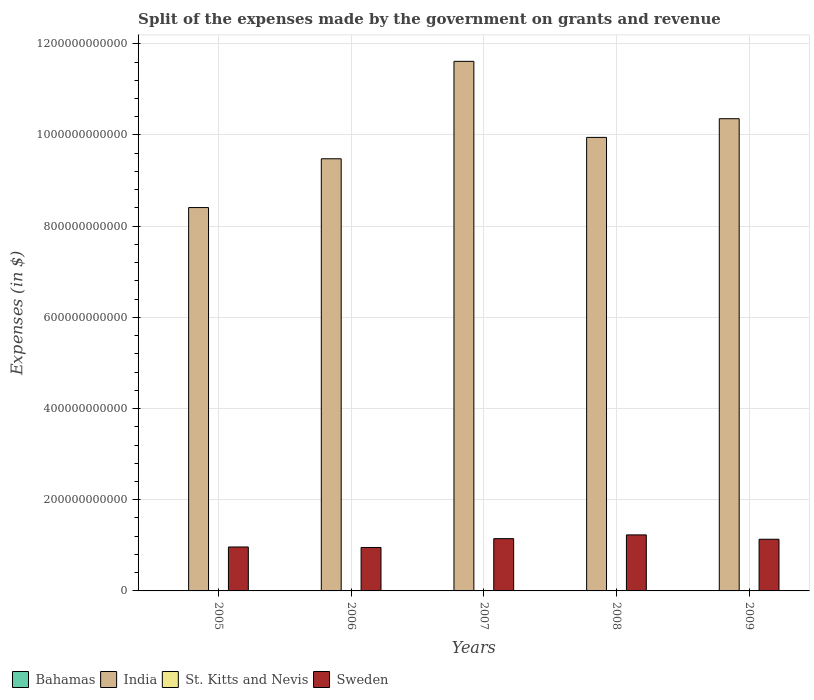In how many cases, is the number of bars for a given year not equal to the number of legend labels?
Your answer should be very brief. 0. What is the expenses made by the government on grants and revenue in St. Kitts and Nevis in 2007?
Give a very brief answer. 1.45e+08. Across all years, what is the maximum expenses made by the government on grants and revenue in India?
Keep it short and to the point. 1.16e+12. Across all years, what is the minimum expenses made by the government on grants and revenue in India?
Your answer should be very brief. 8.41e+11. In which year was the expenses made by the government on grants and revenue in St. Kitts and Nevis maximum?
Offer a terse response. 2009. In which year was the expenses made by the government on grants and revenue in Bahamas minimum?
Give a very brief answer. 2005. What is the total expenses made by the government on grants and revenue in Bahamas in the graph?
Offer a very short reply. 7.34e+08. What is the difference between the expenses made by the government on grants and revenue in Sweden in 2006 and that in 2007?
Ensure brevity in your answer.  -1.94e+1. What is the difference between the expenses made by the government on grants and revenue in India in 2008 and the expenses made by the government on grants and revenue in Sweden in 2006?
Offer a terse response. 8.99e+11. What is the average expenses made by the government on grants and revenue in Bahamas per year?
Keep it short and to the point. 1.47e+08. In the year 2009, what is the difference between the expenses made by the government on grants and revenue in Sweden and expenses made by the government on grants and revenue in Bahamas?
Provide a succinct answer. 1.13e+11. What is the ratio of the expenses made by the government on grants and revenue in India in 2005 to that in 2007?
Your answer should be very brief. 0.72. Is the expenses made by the government on grants and revenue in India in 2005 less than that in 2009?
Your answer should be very brief. Yes. Is the difference between the expenses made by the government on grants and revenue in Sweden in 2006 and 2008 greater than the difference between the expenses made by the government on grants and revenue in Bahamas in 2006 and 2008?
Give a very brief answer. No. What is the difference between the highest and the second highest expenses made by the government on grants and revenue in Sweden?
Your answer should be very brief. 8.23e+09. What is the difference between the highest and the lowest expenses made by the government on grants and revenue in India?
Your response must be concise. 3.21e+11. In how many years, is the expenses made by the government on grants and revenue in St. Kitts and Nevis greater than the average expenses made by the government on grants and revenue in St. Kitts and Nevis taken over all years?
Provide a short and direct response. 1. Is it the case that in every year, the sum of the expenses made by the government on grants and revenue in St. Kitts and Nevis and expenses made by the government on grants and revenue in Bahamas is greater than the sum of expenses made by the government on grants and revenue in Sweden and expenses made by the government on grants and revenue in India?
Provide a short and direct response. No. What does the 2nd bar from the left in 2008 represents?
Keep it short and to the point. India. What does the 3rd bar from the right in 2007 represents?
Offer a terse response. India. How many bars are there?
Give a very brief answer. 20. How many years are there in the graph?
Make the answer very short. 5. What is the difference between two consecutive major ticks on the Y-axis?
Your response must be concise. 2.00e+11. Are the values on the major ticks of Y-axis written in scientific E-notation?
Ensure brevity in your answer.  No. Does the graph contain any zero values?
Offer a terse response. No. How are the legend labels stacked?
Keep it short and to the point. Horizontal. What is the title of the graph?
Your answer should be compact. Split of the expenses made by the government on grants and revenue. Does "Brazil" appear as one of the legend labels in the graph?
Provide a succinct answer. No. What is the label or title of the X-axis?
Offer a terse response. Years. What is the label or title of the Y-axis?
Your answer should be very brief. Expenses (in $). What is the Expenses (in $) of Bahamas in 2005?
Provide a short and direct response. 1.21e+08. What is the Expenses (in $) of India in 2005?
Your answer should be very brief. 8.41e+11. What is the Expenses (in $) of St. Kitts and Nevis in 2005?
Keep it short and to the point. 1.22e+08. What is the Expenses (in $) of Sweden in 2005?
Make the answer very short. 9.64e+1. What is the Expenses (in $) in Bahamas in 2006?
Offer a very short reply. 1.37e+08. What is the Expenses (in $) of India in 2006?
Keep it short and to the point. 9.48e+11. What is the Expenses (in $) in St. Kitts and Nevis in 2006?
Provide a short and direct response. 1.44e+08. What is the Expenses (in $) of Sweden in 2006?
Offer a terse response. 9.53e+1. What is the Expenses (in $) in Bahamas in 2007?
Offer a terse response. 1.30e+08. What is the Expenses (in $) of India in 2007?
Offer a very short reply. 1.16e+12. What is the Expenses (in $) of St. Kitts and Nevis in 2007?
Your response must be concise. 1.45e+08. What is the Expenses (in $) in Sweden in 2007?
Your answer should be very brief. 1.15e+11. What is the Expenses (in $) of Bahamas in 2008?
Provide a short and direct response. 1.53e+08. What is the Expenses (in $) of India in 2008?
Provide a succinct answer. 9.95e+11. What is the Expenses (in $) of St. Kitts and Nevis in 2008?
Offer a terse response. 1.50e+08. What is the Expenses (in $) of Sweden in 2008?
Your answer should be compact. 1.23e+11. What is the Expenses (in $) in Bahamas in 2009?
Make the answer very short. 1.93e+08. What is the Expenses (in $) of India in 2009?
Provide a short and direct response. 1.04e+12. What is the Expenses (in $) of St. Kitts and Nevis in 2009?
Your answer should be compact. 2.10e+08. What is the Expenses (in $) in Sweden in 2009?
Offer a very short reply. 1.13e+11. Across all years, what is the maximum Expenses (in $) of Bahamas?
Ensure brevity in your answer.  1.93e+08. Across all years, what is the maximum Expenses (in $) in India?
Ensure brevity in your answer.  1.16e+12. Across all years, what is the maximum Expenses (in $) of St. Kitts and Nevis?
Give a very brief answer. 2.10e+08. Across all years, what is the maximum Expenses (in $) in Sweden?
Make the answer very short. 1.23e+11. Across all years, what is the minimum Expenses (in $) of Bahamas?
Offer a very short reply. 1.21e+08. Across all years, what is the minimum Expenses (in $) of India?
Provide a succinct answer. 8.41e+11. Across all years, what is the minimum Expenses (in $) of St. Kitts and Nevis?
Your answer should be compact. 1.22e+08. Across all years, what is the minimum Expenses (in $) in Sweden?
Your response must be concise. 9.53e+1. What is the total Expenses (in $) of Bahamas in the graph?
Give a very brief answer. 7.34e+08. What is the total Expenses (in $) of India in the graph?
Your answer should be compact. 4.98e+12. What is the total Expenses (in $) in St. Kitts and Nevis in the graph?
Offer a very short reply. 7.71e+08. What is the total Expenses (in $) of Sweden in the graph?
Your answer should be compact. 5.42e+11. What is the difference between the Expenses (in $) of Bahamas in 2005 and that in 2006?
Your response must be concise. -1.59e+07. What is the difference between the Expenses (in $) of India in 2005 and that in 2006?
Provide a succinct answer. -1.07e+11. What is the difference between the Expenses (in $) of St. Kitts and Nevis in 2005 and that in 2006?
Make the answer very short. -2.26e+07. What is the difference between the Expenses (in $) of Sweden in 2005 and that in 2006?
Make the answer very short. 1.08e+09. What is the difference between the Expenses (in $) in Bahamas in 2005 and that in 2007?
Make the answer very short. -9.02e+06. What is the difference between the Expenses (in $) of India in 2005 and that in 2007?
Offer a terse response. -3.21e+11. What is the difference between the Expenses (in $) in St. Kitts and Nevis in 2005 and that in 2007?
Your answer should be very brief. -2.32e+07. What is the difference between the Expenses (in $) in Sweden in 2005 and that in 2007?
Provide a short and direct response. -1.83e+1. What is the difference between the Expenses (in $) of Bahamas in 2005 and that in 2008?
Offer a terse response. -3.18e+07. What is the difference between the Expenses (in $) of India in 2005 and that in 2008?
Your answer should be very brief. -1.54e+11. What is the difference between the Expenses (in $) of St. Kitts and Nevis in 2005 and that in 2008?
Make the answer very short. -2.87e+07. What is the difference between the Expenses (in $) of Sweden in 2005 and that in 2008?
Keep it short and to the point. -2.65e+1. What is the difference between the Expenses (in $) in Bahamas in 2005 and that in 2009?
Offer a terse response. -7.23e+07. What is the difference between the Expenses (in $) in India in 2005 and that in 2009?
Offer a very short reply. -1.95e+11. What is the difference between the Expenses (in $) in St. Kitts and Nevis in 2005 and that in 2009?
Offer a terse response. -8.77e+07. What is the difference between the Expenses (in $) of Sweden in 2005 and that in 2009?
Provide a short and direct response. -1.70e+1. What is the difference between the Expenses (in $) of Bahamas in 2006 and that in 2007?
Keep it short and to the point. 6.84e+06. What is the difference between the Expenses (in $) in India in 2006 and that in 2007?
Make the answer very short. -2.14e+11. What is the difference between the Expenses (in $) of St. Kitts and Nevis in 2006 and that in 2007?
Give a very brief answer. -6.00e+05. What is the difference between the Expenses (in $) in Sweden in 2006 and that in 2007?
Provide a short and direct response. -1.94e+1. What is the difference between the Expenses (in $) of Bahamas in 2006 and that in 2008?
Offer a terse response. -1.60e+07. What is the difference between the Expenses (in $) in India in 2006 and that in 2008?
Your answer should be very brief. -4.69e+1. What is the difference between the Expenses (in $) in St. Kitts and Nevis in 2006 and that in 2008?
Your answer should be compact. -6.10e+06. What is the difference between the Expenses (in $) in Sweden in 2006 and that in 2008?
Keep it short and to the point. -2.76e+1. What is the difference between the Expenses (in $) in Bahamas in 2006 and that in 2009?
Provide a succinct answer. -5.65e+07. What is the difference between the Expenses (in $) in India in 2006 and that in 2009?
Your answer should be compact. -8.79e+1. What is the difference between the Expenses (in $) of St. Kitts and Nevis in 2006 and that in 2009?
Your answer should be very brief. -6.51e+07. What is the difference between the Expenses (in $) in Sweden in 2006 and that in 2009?
Provide a succinct answer. -1.81e+1. What is the difference between the Expenses (in $) of Bahamas in 2007 and that in 2008?
Make the answer very short. -2.28e+07. What is the difference between the Expenses (in $) of India in 2007 and that in 2008?
Offer a terse response. 1.67e+11. What is the difference between the Expenses (in $) of St. Kitts and Nevis in 2007 and that in 2008?
Keep it short and to the point. -5.50e+06. What is the difference between the Expenses (in $) in Sweden in 2007 and that in 2008?
Give a very brief answer. -8.23e+09. What is the difference between the Expenses (in $) of Bahamas in 2007 and that in 2009?
Your answer should be very brief. -6.33e+07. What is the difference between the Expenses (in $) of India in 2007 and that in 2009?
Ensure brevity in your answer.  1.26e+11. What is the difference between the Expenses (in $) in St. Kitts and Nevis in 2007 and that in 2009?
Ensure brevity in your answer.  -6.45e+07. What is the difference between the Expenses (in $) in Sweden in 2007 and that in 2009?
Ensure brevity in your answer.  1.31e+09. What is the difference between the Expenses (in $) in Bahamas in 2008 and that in 2009?
Ensure brevity in your answer.  -4.05e+07. What is the difference between the Expenses (in $) of India in 2008 and that in 2009?
Your answer should be very brief. -4.10e+1. What is the difference between the Expenses (in $) of St. Kitts and Nevis in 2008 and that in 2009?
Provide a short and direct response. -5.90e+07. What is the difference between the Expenses (in $) of Sweden in 2008 and that in 2009?
Your response must be concise. 9.54e+09. What is the difference between the Expenses (in $) of Bahamas in 2005 and the Expenses (in $) of India in 2006?
Make the answer very short. -9.48e+11. What is the difference between the Expenses (in $) of Bahamas in 2005 and the Expenses (in $) of St. Kitts and Nevis in 2006?
Keep it short and to the point. -2.34e+07. What is the difference between the Expenses (in $) in Bahamas in 2005 and the Expenses (in $) in Sweden in 2006?
Your response must be concise. -9.51e+1. What is the difference between the Expenses (in $) in India in 2005 and the Expenses (in $) in St. Kitts and Nevis in 2006?
Keep it short and to the point. 8.41e+11. What is the difference between the Expenses (in $) in India in 2005 and the Expenses (in $) in Sweden in 2006?
Your answer should be compact. 7.45e+11. What is the difference between the Expenses (in $) in St. Kitts and Nevis in 2005 and the Expenses (in $) in Sweden in 2006?
Make the answer very short. -9.51e+1. What is the difference between the Expenses (in $) of Bahamas in 2005 and the Expenses (in $) of India in 2007?
Your response must be concise. -1.16e+12. What is the difference between the Expenses (in $) of Bahamas in 2005 and the Expenses (in $) of St. Kitts and Nevis in 2007?
Provide a succinct answer. -2.40e+07. What is the difference between the Expenses (in $) of Bahamas in 2005 and the Expenses (in $) of Sweden in 2007?
Ensure brevity in your answer.  -1.15e+11. What is the difference between the Expenses (in $) in India in 2005 and the Expenses (in $) in St. Kitts and Nevis in 2007?
Provide a succinct answer. 8.41e+11. What is the difference between the Expenses (in $) of India in 2005 and the Expenses (in $) of Sweden in 2007?
Give a very brief answer. 7.26e+11. What is the difference between the Expenses (in $) of St. Kitts and Nevis in 2005 and the Expenses (in $) of Sweden in 2007?
Your response must be concise. -1.15e+11. What is the difference between the Expenses (in $) in Bahamas in 2005 and the Expenses (in $) in India in 2008?
Your answer should be compact. -9.95e+11. What is the difference between the Expenses (in $) of Bahamas in 2005 and the Expenses (in $) of St. Kitts and Nevis in 2008?
Offer a very short reply. -2.95e+07. What is the difference between the Expenses (in $) in Bahamas in 2005 and the Expenses (in $) in Sweden in 2008?
Provide a succinct answer. -1.23e+11. What is the difference between the Expenses (in $) of India in 2005 and the Expenses (in $) of St. Kitts and Nevis in 2008?
Your answer should be very brief. 8.41e+11. What is the difference between the Expenses (in $) in India in 2005 and the Expenses (in $) in Sweden in 2008?
Provide a short and direct response. 7.18e+11. What is the difference between the Expenses (in $) of St. Kitts and Nevis in 2005 and the Expenses (in $) of Sweden in 2008?
Your answer should be very brief. -1.23e+11. What is the difference between the Expenses (in $) in Bahamas in 2005 and the Expenses (in $) in India in 2009?
Ensure brevity in your answer.  -1.04e+12. What is the difference between the Expenses (in $) of Bahamas in 2005 and the Expenses (in $) of St. Kitts and Nevis in 2009?
Provide a succinct answer. -8.85e+07. What is the difference between the Expenses (in $) in Bahamas in 2005 and the Expenses (in $) in Sweden in 2009?
Ensure brevity in your answer.  -1.13e+11. What is the difference between the Expenses (in $) of India in 2005 and the Expenses (in $) of St. Kitts and Nevis in 2009?
Keep it short and to the point. 8.41e+11. What is the difference between the Expenses (in $) in India in 2005 and the Expenses (in $) in Sweden in 2009?
Ensure brevity in your answer.  7.27e+11. What is the difference between the Expenses (in $) in St. Kitts and Nevis in 2005 and the Expenses (in $) in Sweden in 2009?
Provide a succinct answer. -1.13e+11. What is the difference between the Expenses (in $) of Bahamas in 2006 and the Expenses (in $) of India in 2007?
Provide a succinct answer. -1.16e+12. What is the difference between the Expenses (in $) in Bahamas in 2006 and the Expenses (in $) in St. Kitts and Nevis in 2007?
Make the answer very short. -8.17e+06. What is the difference between the Expenses (in $) of Bahamas in 2006 and the Expenses (in $) of Sweden in 2007?
Offer a very short reply. -1.15e+11. What is the difference between the Expenses (in $) of India in 2006 and the Expenses (in $) of St. Kitts and Nevis in 2007?
Offer a terse response. 9.48e+11. What is the difference between the Expenses (in $) of India in 2006 and the Expenses (in $) of Sweden in 2007?
Offer a terse response. 8.33e+11. What is the difference between the Expenses (in $) of St. Kitts and Nevis in 2006 and the Expenses (in $) of Sweden in 2007?
Keep it short and to the point. -1.14e+11. What is the difference between the Expenses (in $) in Bahamas in 2006 and the Expenses (in $) in India in 2008?
Offer a terse response. -9.95e+11. What is the difference between the Expenses (in $) of Bahamas in 2006 and the Expenses (in $) of St. Kitts and Nevis in 2008?
Provide a succinct answer. -1.37e+07. What is the difference between the Expenses (in $) of Bahamas in 2006 and the Expenses (in $) of Sweden in 2008?
Make the answer very short. -1.23e+11. What is the difference between the Expenses (in $) in India in 2006 and the Expenses (in $) in St. Kitts and Nevis in 2008?
Keep it short and to the point. 9.48e+11. What is the difference between the Expenses (in $) in India in 2006 and the Expenses (in $) in Sweden in 2008?
Keep it short and to the point. 8.25e+11. What is the difference between the Expenses (in $) of St. Kitts and Nevis in 2006 and the Expenses (in $) of Sweden in 2008?
Provide a short and direct response. -1.23e+11. What is the difference between the Expenses (in $) of Bahamas in 2006 and the Expenses (in $) of India in 2009?
Provide a succinct answer. -1.04e+12. What is the difference between the Expenses (in $) in Bahamas in 2006 and the Expenses (in $) in St. Kitts and Nevis in 2009?
Provide a succinct answer. -7.27e+07. What is the difference between the Expenses (in $) of Bahamas in 2006 and the Expenses (in $) of Sweden in 2009?
Offer a very short reply. -1.13e+11. What is the difference between the Expenses (in $) of India in 2006 and the Expenses (in $) of St. Kitts and Nevis in 2009?
Make the answer very short. 9.48e+11. What is the difference between the Expenses (in $) of India in 2006 and the Expenses (in $) of Sweden in 2009?
Your answer should be compact. 8.34e+11. What is the difference between the Expenses (in $) in St. Kitts and Nevis in 2006 and the Expenses (in $) in Sweden in 2009?
Make the answer very short. -1.13e+11. What is the difference between the Expenses (in $) of Bahamas in 2007 and the Expenses (in $) of India in 2008?
Provide a short and direct response. -9.95e+11. What is the difference between the Expenses (in $) of Bahamas in 2007 and the Expenses (in $) of St. Kitts and Nevis in 2008?
Provide a short and direct response. -2.05e+07. What is the difference between the Expenses (in $) in Bahamas in 2007 and the Expenses (in $) in Sweden in 2008?
Keep it short and to the point. -1.23e+11. What is the difference between the Expenses (in $) in India in 2007 and the Expenses (in $) in St. Kitts and Nevis in 2008?
Provide a succinct answer. 1.16e+12. What is the difference between the Expenses (in $) of India in 2007 and the Expenses (in $) of Sweden in 2008?
Your answer should be compact. 1.04e+12. What is the difference between the Expenses (in $) in St. Kitts and Nevis in 2007 and the Expenses (in $) in Sweden in 2008?
Give a very brief answer. -1.23e+11. What is the difference between the Expenses (in $) in Bahamas in 2007 and the Expenses (in $) in India in 2009?
Keep it short and to the point. -1.04e+12. What is the difference between the Expenses (in $) in Bahamas in 2007 and the Expenses (in $) in St. Kitts and Nevis in 2009?
Make the answer very short. -7.95e+07. What is the difference between the Expenses (in $) in Bahamas in 2007 and the Expenses (in $) in Sweden in 2009?
Make the answer very short. -1.13e+11. What is the difference between the Expenses (in $) in India in 2007 and the Expenses (in $) in St. Kitts and Nevis in 2009?
Make the answer very short. 1.16e+12. What is the difference between the Expenses (in $) in India in 2007 and the Expenses (in $) in Sweden in 2009?
Your answer should be very brief. 1.05e+12. What is the difference between the Expenses (in $) in St. Kitts and Nevis in 2007 and the Expenses (in $) in Sweden in 2009?
Offer a very short reply. -1.13e+11. What is the difference between the Expenses (in $) of Bahamas in 2008 and the Expenses (in $) of India in 2009?
Provide a succinct answer. -1.04e+12. What is the difference between the Expenses (in $) of Bahamas in 2008 and the Expenses (in $) of St. Kitts and Nevis in 2009?
Provide a short and direct response. -5.67e+07. What is the difference between the Expenses (in $) of Bahamas in 2008 and the Expenses (in $) of Sweden in 2009?
Provide a succinct answer. -1.13e+11. What is the difference between the Expenses (in $) in India in 2008 and the Expenses (in $) in St. Kitts and Nevis in 2009?
Your answer should be very brief. 9.94e+11. What is the difference between the Expenses (in $) in India in 2008 and the Expenses (in $) in Sweden in 2009?
Keep it short and to the point. 8.81e+11. What is the difference between the Expenses (in $) of St. Kitts and Nevis in 2008 and the Expenses (in $) of Sweden in 2009?
Your response must be concise. -1.13e+11. What is the average Expenses (in $) of Bahamas per year?
Provide a succinct answer. 1.47e+08. What is the average Expenses (in $) of India per year?
Provide a succinct answer. 9.96e+11. What is the average Expenses (in $) in St. Kitts and Nevis per year?
Your answer should be compact. 1.54e+08. What is the average Expenses (in $) in Sweden per year?
Keep it short and to the point. 1.08e+11. In the year 2005, what is the difference between the Expenses (in $) of Bahamas and Expenses (in $) of India?
Provide a short and direct response. -8.41e+11. In the year 2005, what is the difference between the Expenses (in $) in Bahamas and Expenses (in $) in St. Kitts and Nevis?
Your answer should be very brief. -8.21e+05. In the year 2005, what is the difference between the Expenses (in $) of Bahamas and Expenses (in $) of Sweden?
Provide a short and direct response. -9.62e+1. In the year 2005, what is the difference between the Expenses (in $) in India and Expenses (in $) in St. Kitts and Nevis?
Give a very brief answer. 8.41e+11. In the year 2005, what is the difference between the Expenses (in $) of India and Expenses (in $) of Sweden?
Offer a very short reply. 7.44e+11. In the year 2005, what is the difference between the Expenses (in $) in St. Kitts and Nevis and Expenses (in $) in Sweden?
Keep it short and to the point. -9.62e+1. In the year 2006, what is the difference between the Expenses (in $) of Bahamas and Expenses (in $) of India?
Ensure brevity in your answer.  -9.48e+11. In the year 2006, what is the difference between the Expenses (in $) in Bahamas and Expenses (in $) in St. Kitts and Nevis?
Make the answer very short. -7.57e+06. In the year 2006, what is the difference between the Expenses (in $) of Bahamas and Expenses (in $) of Sweden?
Your response must be concise. -9.51e+1. In the year 2006, what is the difference between the Expenses (in $) in India and Expenses (in $) in St. Kitts and Nevis?
Your response must be concise. 9.48e+11. In the year 2006, what is the difference between the Expenses (in $) in India and Expenses (in $) in Sweden?
Give a very brief answer. 8.52e+11. In the year 2006, what is the difference between the Expenses (in $) in St. Kitts and Nevis and Expenses (in $) in Sweden?
Your answer should be very brief. -9.51e+1. In the year 2007, what is the difference between the Expenses (in $) in Bahamas and Expenses (in $) in India?
Give a very brief answer. -1.16e+12. In the year 2007, what is the difference between the Expenses (in $) in Bahamas and Expenses (in $) in St. Kitts and Nevis?
Your response must be concise. -1.50e+07. In the year 2007, what is the difference between the Expenses (in $) of Bahamas and Expenses (in $) of Sweden?
Your answer should be compact. -1.15e+11. In the year 2007, what is the difference between the Expenses (in $) in India and Expenses (in $) in St. Kitts and Nevis?
Make the answer very short. 1.16e+12. In the year 2007, what is the difference between the Expenses (in $) in India and Expenses (in $) in Sweden?
Offer a terse response. 1.05e+12. In the year 2007, what is the difference between the Expenses (in $) of St. Kitts and Nevis and Expenses (in $) of Sweden?
Offer a terse response. -1.14e+11. In the year 2008, what is the difference between the Expenses (in $) in Bahamas and Expenses (in $) in India?
Your response must be concise. -9.94e+11. In the year 2008, what is the difference between the Expenses (in $) in Bahamas and Expenses (in $) in St. Kitts and Nevis?
Your answer should be compact. 2.31e+06. In the year 2008, what is the difference between the Expenses (in $) in Bahamas and Expenses (in $) in Sweden?
Your answer should be compact. -1.23e+11. In the year 2008, what is the difference between the Expenses (in $) of India and Expenses (in $) of St. Kitts and Nevis?
Offer a very short reply. 9.94e+11. In the year 2008, what is the difference between the Expenses (in $) in India and Expenses (in $) in Sweden?
Offer a very short reply. 8.72e+11. In the year 2008, what is the difference between the Expenses (in $) of St. Kitts and Nevis and Expenses (in $) of Sweden?
Provide a short and direct response. -1.23e+11. In the year 2009, what is the difference between the Expenses (in $) of Bahamas and Expenses (in $) of India?
Provide a short and direct response. -1.04e+12. In the year 2009, what is the difference between the Expenses (in $) of Bahamas and Expenses (in $) of St. Kitts and Nevis?
Offer a terse response. -1.62e+07. In the year 2009, what is the difference between the Expenses (in $) of Bahamas and Expenses (in $) of Sweden?
Keep it short and to the point. -1.13e+11. In the year 2009, what is the difference between the Expenses (in $) in India and Expenses (in $) in St. Kitts and Nevis?
Your response must be concise. 1.04e+12. In the year 2009, what is the difference between the Expenses (in $) of India and Expenses (in $) of Sweden?
Make the answer very short. 9.22e+11. In the year 2009, what is the difference between the Expenses (in $) in St. Kitts and Nevis and Expenses (in $) in Sweden?
Provide a short and direct response. -1.13e+11. What is the ratio of the Expenses (in $) of Bahamas in 2005 to that in 2006?
Your answer should be compact. 0.88. What is the ratio of the Expenses (in $) in India in 2005 to that in 2006?
Your answer should be compact. 0.89. What is the ratio of the Expenses (in $) in St. Kitts and Nevis in 2005 to that in 2006?
Make the answer very short. 0.84. What is the ratio of the Expenses (in $) of Sweden in 2005 to that in 2006?
Provide a succinct answer. 1.01. What is the ratio of the Expenses (in $) in Bahamas in 2005 to that in 2007?
Your answer should be compact. 0.93. What is the ratio of the Expenses (in $) of India in 2005 to that in 2007?
Keep it short and to the point. 0.72. What is the ratio of the Expenses (in $) of St. Kitts and Nevis in 2005 to that in 2007?
Provide a succinct answer. 0.84. What is the ratio of the Expenses (in $) of Sweden in 2005 to that in 2007?
Offer a terse response. 0.84. What is the ratio of the Expenses (in $) in Bahamas in 2005 to that in 2008?
Make the answer very short. 0.79. What is the ratio of the Expenses (in $) in India in 2005 to that in 2008?
Ensure brevity in your answer.  0.85. What is the ratio of the Expenses (in $) of St. Kitts and Nevis in 2005 to that in 2008?
Offer a very short reply. 0.81. What is the ratio of the Expenses (in $) in Sweden in 2005 to that in 2008?
Your response must be concise. 0.78. What is the ratio of the Expenses (in $) in Bahamas in 2005 to that in 2009?
Ensure brevity in your answer.  0.63. What is the ratio of the Expenses (in $) in India in 2005 to that in 2009?
Keep it short and to the point. 0.81. What is the ratio of the Expenses (in $) of St. Kitts and Nevis in 2005 to that in 2009?
Give a very brief answer. 0.58. What is the ratio of the Expenses (in $) of Sweden in 2005 to that in 2009?
Offer a very short reply. 0.85. What is the ratio of the Expenses (in $) in Bahamas in 2006 to that in 2007?
Your answer should be very brief. 1.05. What is the ratio of the Expenses (in $) of India in 2006 to that in 2007?
Ensure brevity in your answer.  0.82. What is the ratio of the Expenses (in $) in St. Kitts and Nevis in 2006 to that in 2007?
Ensure brevity in your answer.  1. What is the ratio of the Expenses (in $) in Sweden in 2006 to that in 2007?
Your answer should be compact. 0.83. What is the ratio of the Expenses (in $) in Bahamas in 2006 to that in 2008?
Make the answer very short. 0.9. What is the ratio of the Expenses (in $) of India in 2006 to that in 2008?
Make the answer very short. 0.95. What is the ratio of the Expenses (in $) of St. Kitts and Nevis in 2006 to that in 2008?
Keep it short and to the point. 0.96. What is the ratio of the Expenses (in $) of Sweden in 2006 to that in 2008?
Your answer should be compact. 0.78. What is the ratio of the Expenses (in $) in Bahamas in 2006 to that in 2009?
Keep it short and to the point. 0.71. What is the ratio of the Expenses (in $) of India in 2006 to that in 2009?
Your answer should be very brief. 0.92. What is the ratio of the Expenses (in $) of St. Kitts and Nevis in 2006 to that in 2009?
Offer a very short reply. 0.69. What is the ratio of the Expenses (in $) of Sweden in 2006 to that in 2009?
Ensure brevity in your answer.  0.84. What is the ratio of the Expenses (in $) in Bahamas in 2007 to that in 2008?
Provide a short and direct response. 0.85. What is the ratio of the Expenses (in $) of India in 2007 to that in 2008?
Your answer should be compact. 1.17. What is the ratio of the Expenses (in $) in St. Kitts and Nevis in 2007 to that in 2008?
Ensure brevity in your answer.  0.96. What is the ratio of the Expenses (in $) in Sweden in 2007 to that in 2008?
Give a very brief answer. 0.93. What is the ratio of the Expenses (in $) of Bahamas in 2007 to that in 2009?
Keep it short and to the point. 0.67. What is the ratio of the Expenses (in $) in India in 2007 to that in 2009?
Make the answer very short. 1.12. What is the ratio of the Expenses (in $) in St. Kitts and Nevis in 2007 to that in 2009?
Keep it short and to the point. 0.69. What is the ratio of the Expenses (in $) of Sweden in 2007 to that in 2009?
Give a very brief answer. 1.01. What is the ratio of the Expenses (in $) of Bahamas in 2008 to that in 2009?
Your answer should be compact. 0.79. What is the ratio of the Expenses (in $) of India in 2008 to that in 2009?
Keep it short and to the point. 0.96. What is the ratio of the Expenses (in $) in St. Kitts and Nevis in 2008 to that in 2009?
Offer a very short reply. 0.72. What is the ratio of the Expenses (in $) of Sweden in 2008 to that in 2009?
Provide a short and direct response. 1.08. What is the difference between the highest and the second highest Expenses (in $) in Bahamas?
Provide a short and direct response. 4.05e+07. What is the difference between the highest and the second highest Expenses (in $) of India?
Provide a succinct answer. 1.26e+11. What is the difference between the highest and the second highest Expenses (in $) in St. Kitts and Nevis?
Offer a terse response. 5.90e+07. What is the difference between the highest and the second highest Expenses (in $) of Sweden?
Provide a short and direct response. 8.23e+09. What is the difference between the highest and the lowest Expenses (in $) in Bahamas?
Offer a terse response. 7.23e+07. What is the difference between the highest and the lowest Expenses (in $) of India?
Your answer should be compact. 3.21e+11. What is the difference between the highest and the lowest Expenses (in $) of St. Kitts and Nevis?
Offer a very short reply. 8.77e+07. What is the difference between the highest and the lowest Expenses (in $) in Sweden?
Keep it short and to the point. 2.76e+1. 